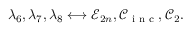Convert formula to latex. <formula><loc_0><loc_0><loc_500><loc_500>\lambda _ { 6 } , \lambda _ { 7 } , \lambda _ { 8 } \longleftrightarrow \mathcal { E } _ { 2 n } , \mathcal { C } _ { i n c } , \mathcal { C } _ { 2 } .</formula> 